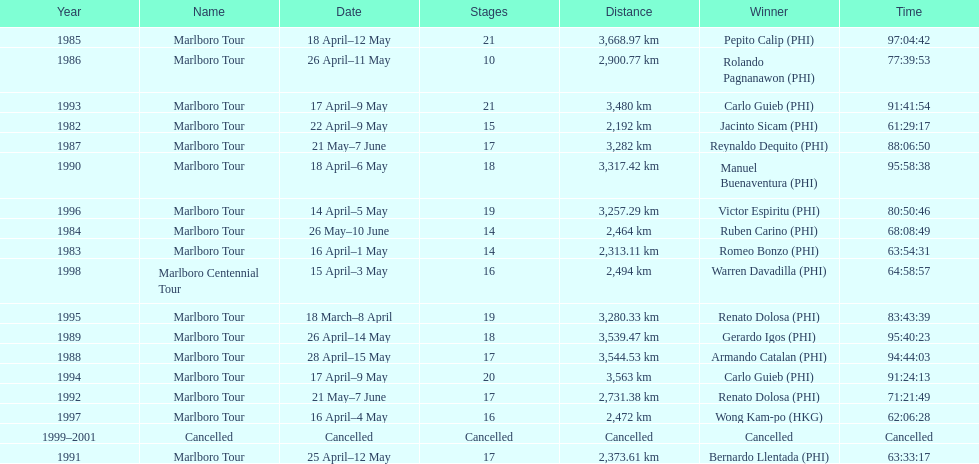What was the largest distance traveled for the marlboro tour? 3,668.97 km. 